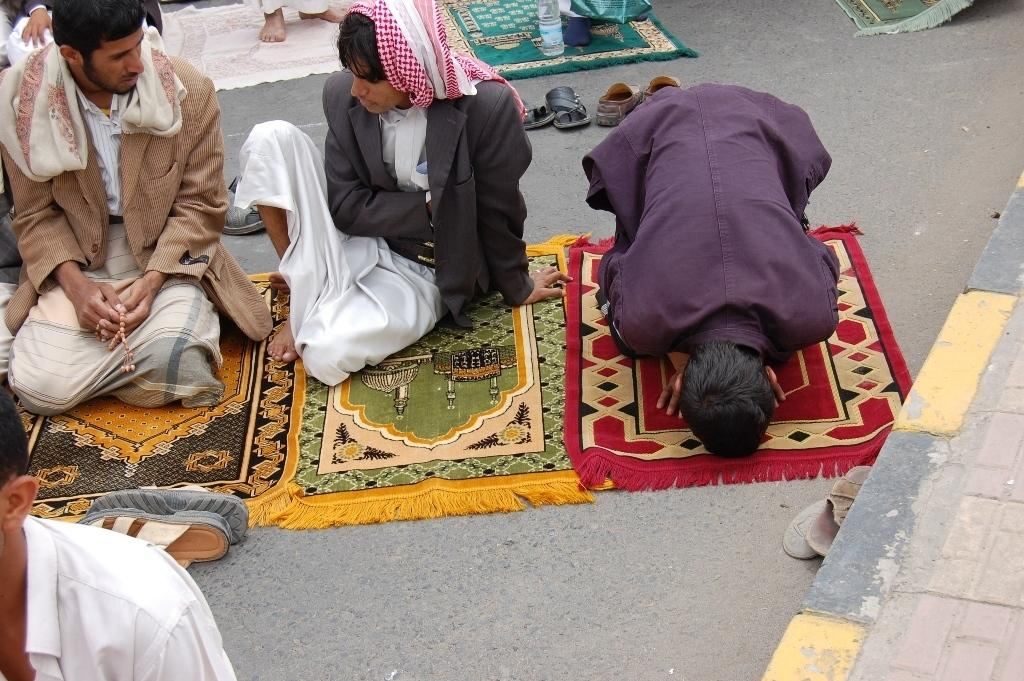What are the people in the image doing? The people appear to be praying in the image. Where are the people sitting? The people are sitting on mats in the image. What is the location of the mats? The mats are placed on the road. What can be seen on the right side of the image? There is a footpath on the right side of the image. How many horses are visible in the image? There are no horses present in the image. What type of spacecraft can be seen in the image? There is no spacecraft present in the image. 